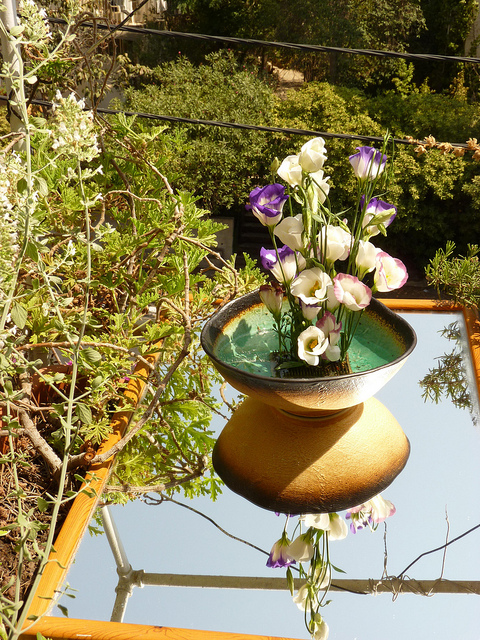<image>What kind of flowers are these? I don't know what kind of flowers these are. They could be tulips, lilies, iris or roses. What kind of flowers are these? I don't know what kind of flowers are these. They can be tulip, iris, lilies or rose. 